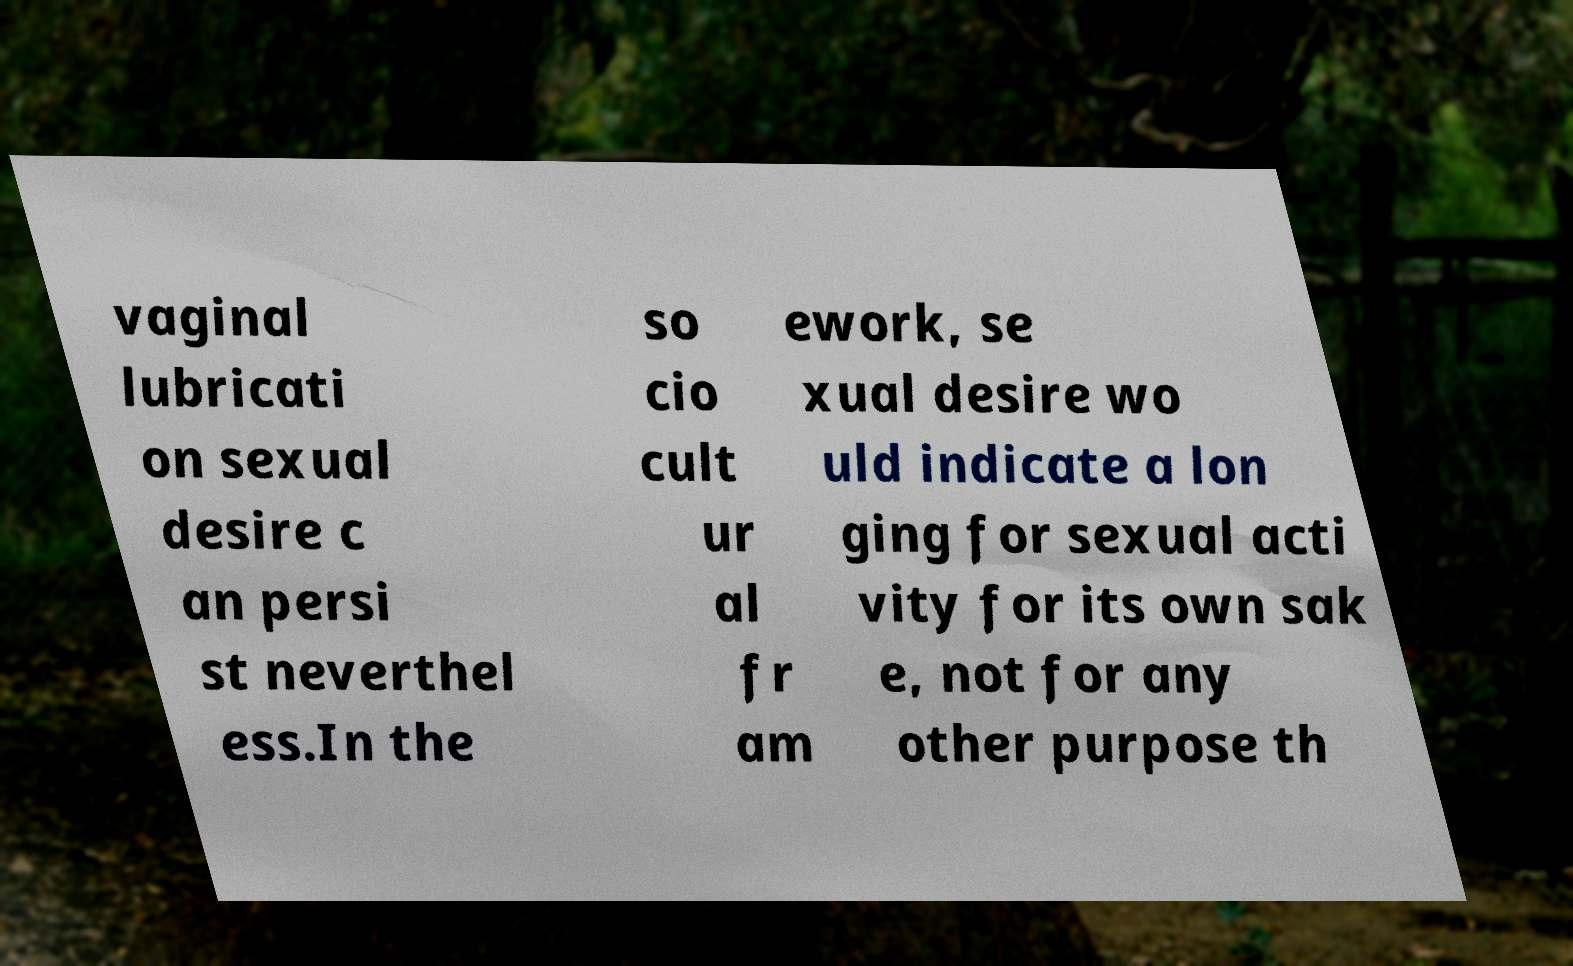There's text embedded in this image that I need extracted. Can you transcribe it verbatim? vaginal lubricati on sexual desire c an persi st neverthel ess.In the so cio cult ur al fr am ework, se xual desire wo uld indicate a lon ging for sexual acti vity for its own sak e, not for any other purpose th 